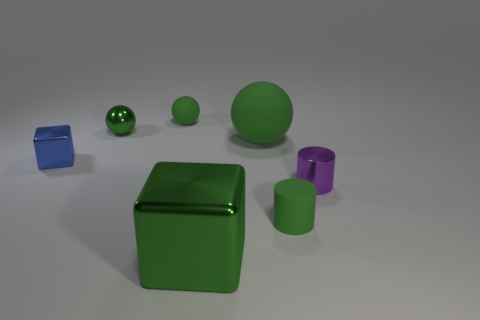How many green balls must be subtracted to get 2 green balls? 1 Add 3 blocks. How many objects exist? 10 Subtract all cylinders. How many objects are left? 5 Subtract 0 cyan balls. How many objects are left? 7 Subtract all large green matte spheres. Subtract all tiny green rubber spheres. How many objects are left? 5 Add 2 small matte balls. How many small matte balls are left? 3 Add 3 small purple cylinders. How many small purple cylinders exist? 4 